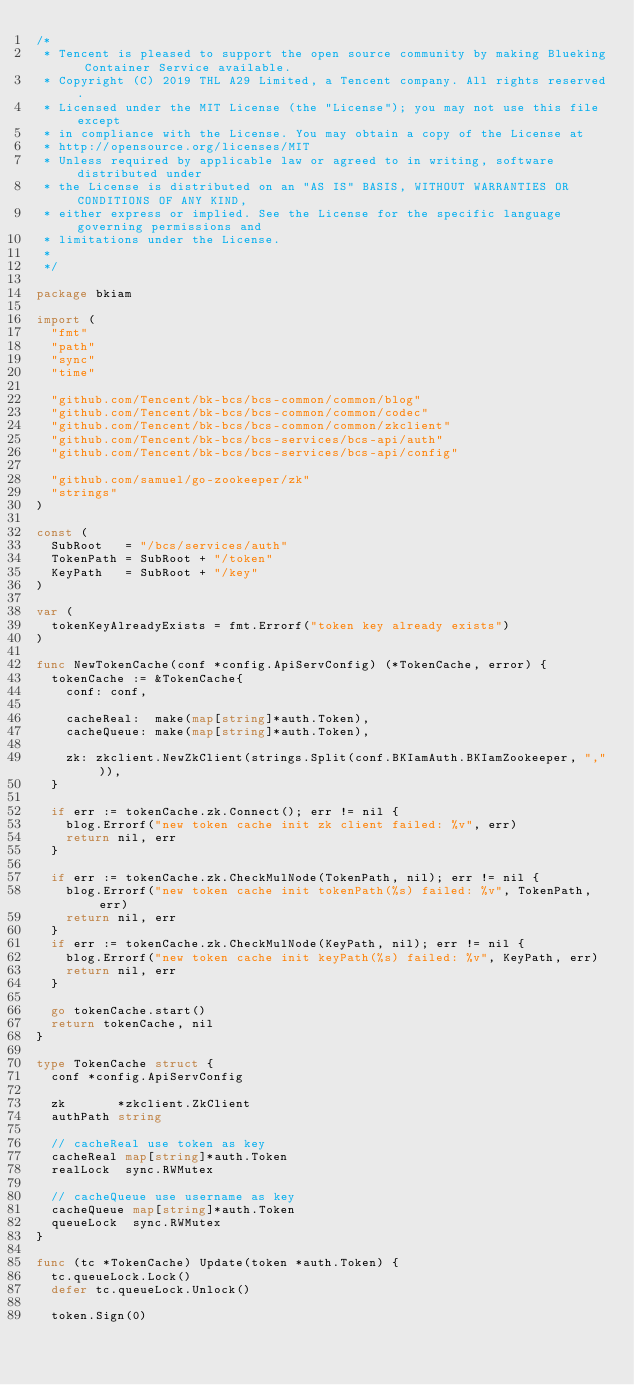<code> <loc_0><loc_0><loc_500><loc_500><_Go_>/*
 * Tencent is pleased to support the open source community by making Blueking Container Service available.
 * Copyright (C) 2019 THL A29 Limited, a Tencent company. All rights reserved.
 * Licensed under the MIT License (the "License"); you may not use this file except
 * in compliance with the License. You may obtain a copy of the License at
 * http://opensource.org/licenses/MIT
 * Unless required by applicable law or agreed to in writing, software distributed under
 * the License is distributed on an "AS IS" BASIS, WITHOUT WARRANTIES OR CONDITIONS OF ANY KIND,
 * either express or implied. See the License for the specific language governing permissions and
 * limitations under the License.
 *
 */

package bkiam

import (
	"fmt"
	"path"
	"sync"
	"time"

	"github.com/Tencent/bk-bcs/bcs-common/common/blog"
	"github.com/Tencent/bk-bcs/bcs-common/common/codec"
	"github.com/Tencent/bk-bcs/bcs-common/common/zkclient"
	"github.com/Tencent/bk-bcs/bcs-services/bcs-api/auth"
	"github.com/Tencent/bk-bcs/bcs-services/bcs-api/config"

	"github.com/samuel/go-zookeeper/zk"
	"strings"
)

const (
	SubRoot   = "/bcs/services/auth"
	TokenPath = SubRoot + "/token"
	KeyPath   = SubRoot + "/key"
)

var (
	tokenKeyAlreadyExists = fmt.Errorf("token key already exists")
)

func NewTokenCache(conf *config.ApiServConfig) (*TokenCache, error) {
	tokenCache := &TokenCache{
		conf: conf,

		cacheReal:  make(map[string]*auth.Token),
		cacheQueue: make(map[string]*auth.Token),

		zk: zkclient.NewZkClient(strings.Split(conf.BKIamAuth.BKIamZookeeper, ",")),
	}

	if err := tokenCache.zk.Connect(); err != nil {
		blog.Errorf("new token cache init zk client failed: %v", err)
		return nil, err
	}

	if err := tokenCache.zk.CheckMulNode(TokenPath, nil); err != nil {
		blog.Errorf("new token cache init tokenPath(%s) failed: %v", TokenPath, err)
		return nil, err
	}
	if err := tokenCache.zk.CheckMulNode(KeyPath, nil); err != nil {
		blog.Errorf("new token cache init keyPath(%s) failed: %v", KeyPath, err)
		return nil, err
	}

	go tokenCache.start()
	return tokenCache, nil
}

type TokenCache struct {
	conf *config.ApiServConfig

	zk       *zkclient.ZkClient
	authPath string

	// cacheReal use token as key
	cacheReal map[string]*auth.Token
	realLock  sync.RWMutex

	// cacheQueue use username as key
	cacheQueue map[string]*auth.Token
	queueLock  sync.RWMutex
}

func (tc *TokenCache) Update(token *auth.Token) {
	tc.queueLock.Lock()
	defer tc.queueLock.Unlock()

	token.Sign(0)</code> 